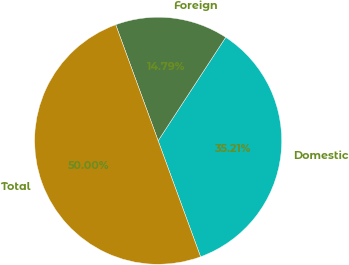Convert chart. <chart><loc_0><loc_0><loc_500><loc_500><pie_chart><fcel>Domestic<fcel>Foreign<fcel>Total<nl><fcel>35.21%<fcel>14.79%<fcel>50.0%<nl></chart> 